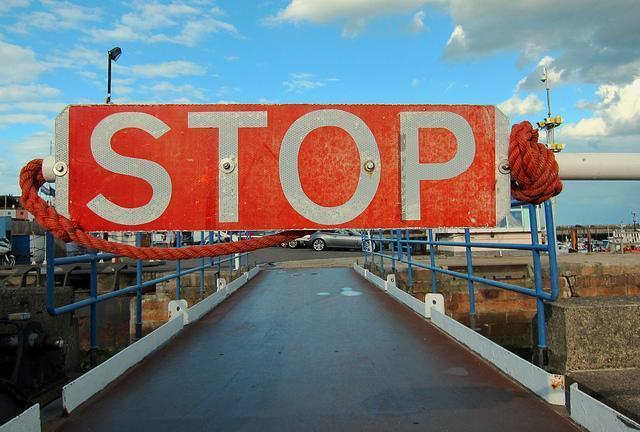How many people are riding the bike farthest to the left?
Give a very brief answer. 0. 